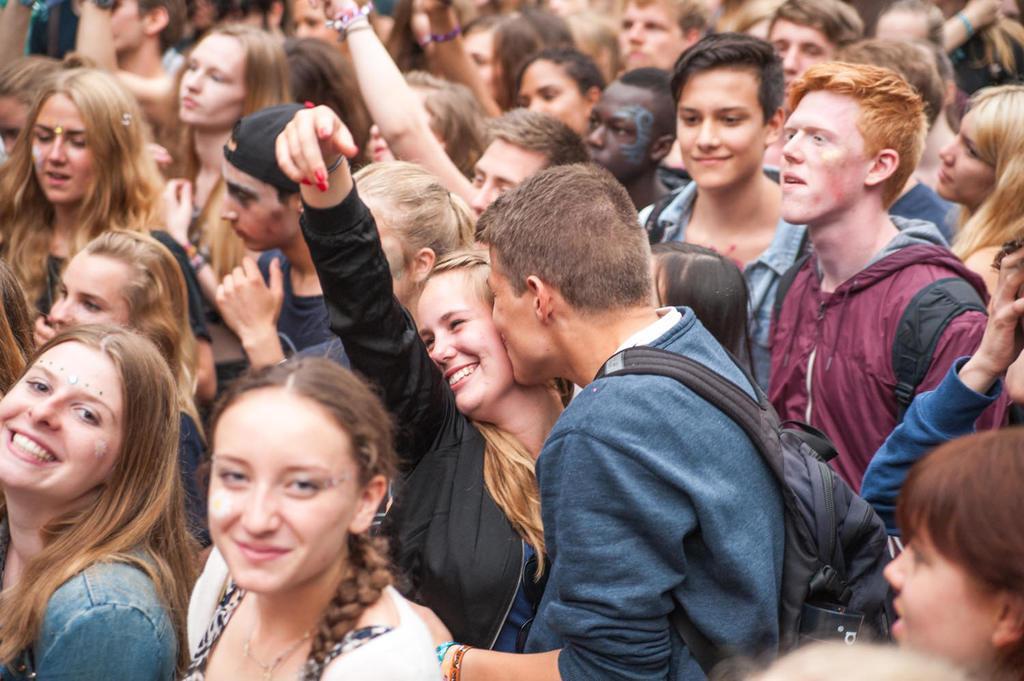In one or two sentences, can you explain what this image depicts? In this image I can see a group of people among them a man is kissing a woman. The man is wearing a bag. Some people are smiling. 